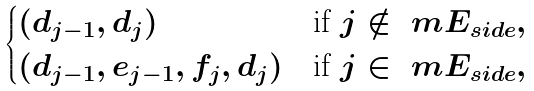<formula> <loc_0><loc_0><loc_500><loc_500>\begin{cases} ( d _ { j - 1 } , d _ { j } ) & \text {if } j \notin \ m E _ { s i d e } , \\ ( d _ { j - 1 } , e _ { j - 1 } , f _ { j } , d _ { j } ) & \text {if } j \in \ m E _ { s i d e } , \end{cases}</formula> 